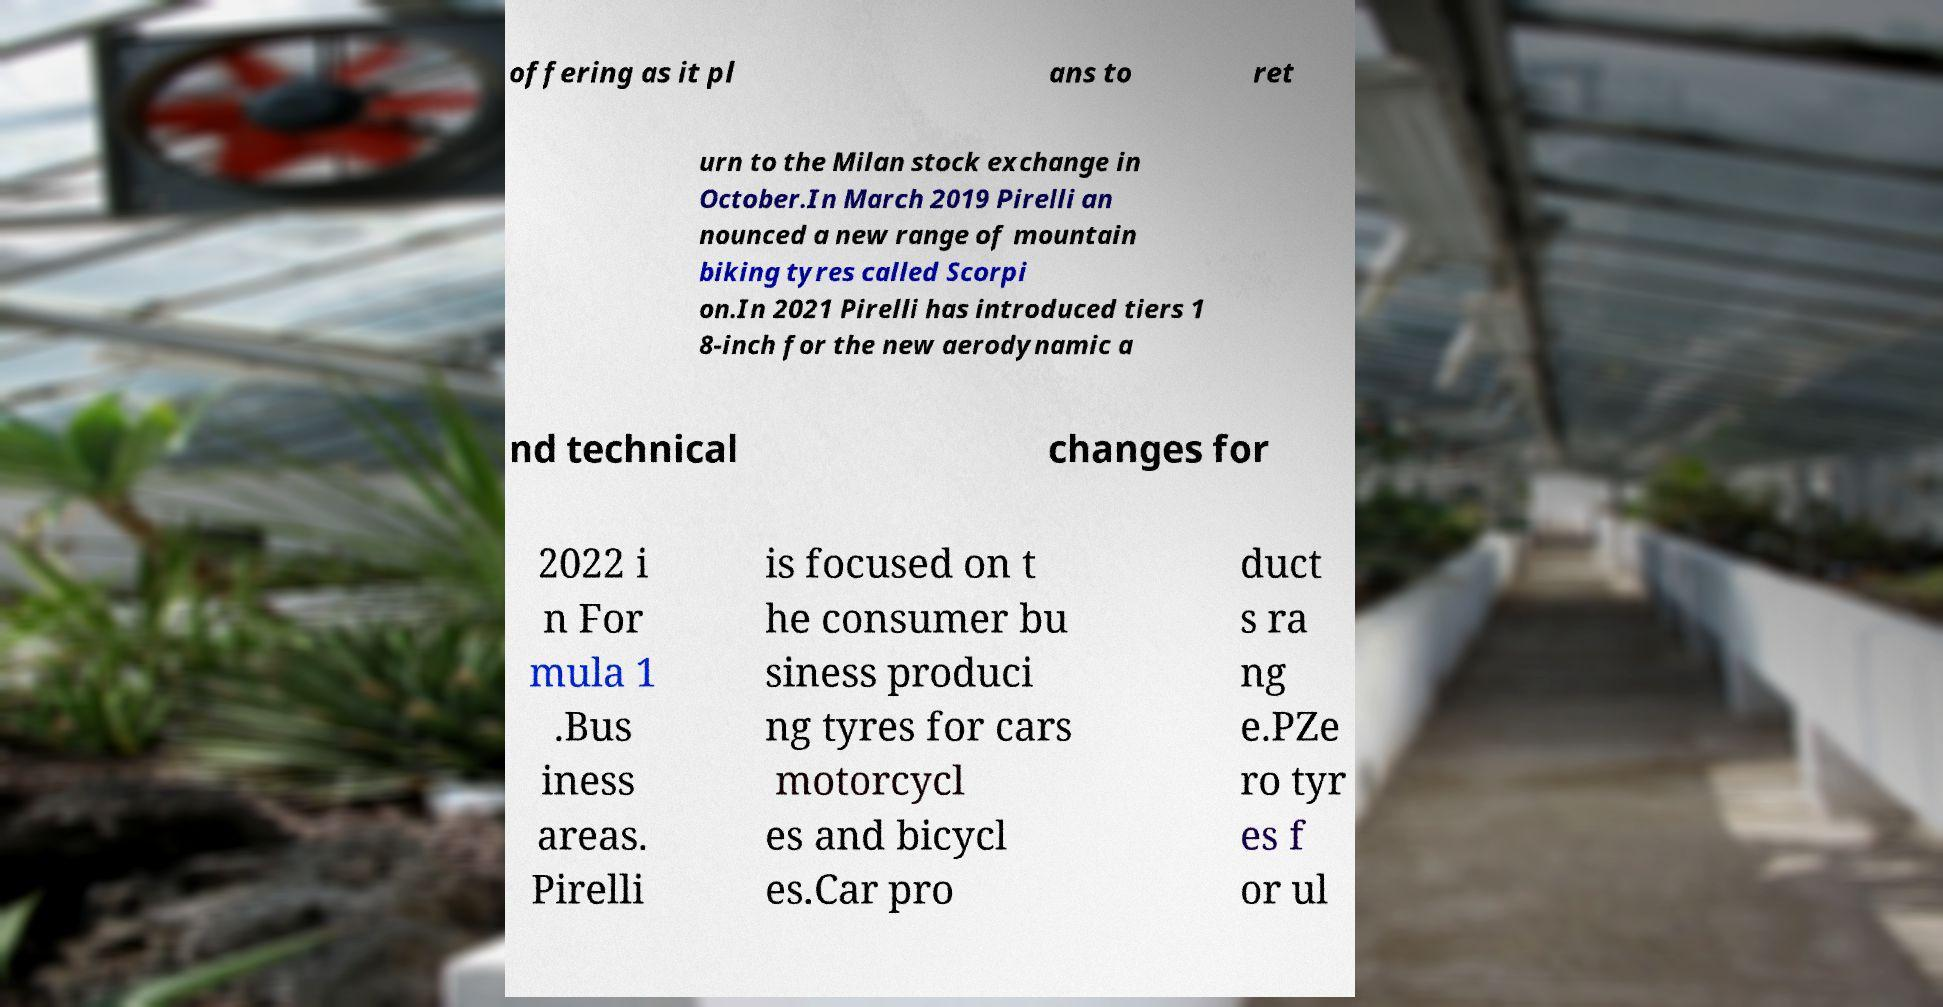For documentation purposes, I need the text within this image transcribed. Could you provide that? offering as it pl ans to ret urn to the Milan stock exchange in October.In March 2019 Pirelli an nounced a new range of mountain biking tyres called Scorpi on.In 2021 Pirelli has introduced tiers 1 8-inch for the new aerodynamic a nd technical changes for 2022 i n For mula 1 .Bus iness areas. Pirelli is focused on t he consumer bu siness produci ng tyres for cars motorcycl es and bicycl es.Car pro duct s ra ng e.PZe ro tyr es f or ul 